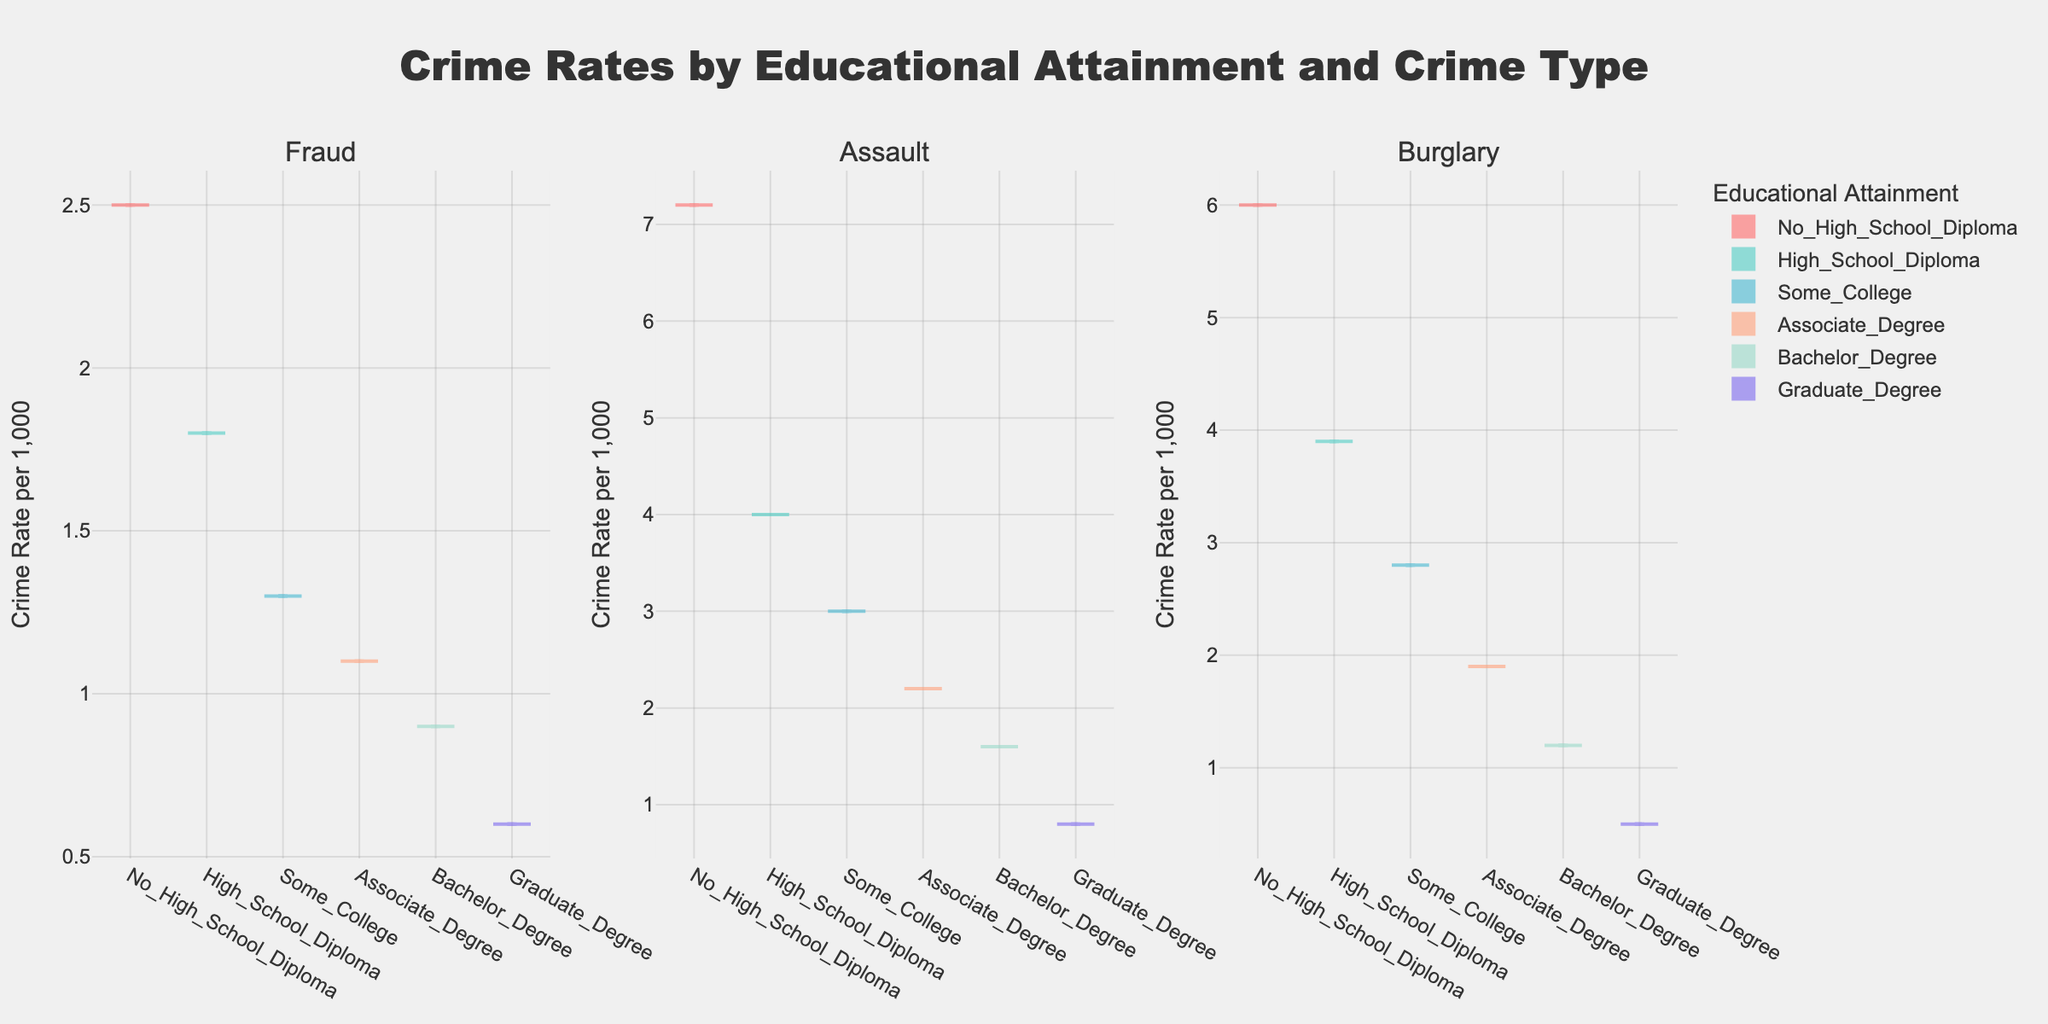What is the title of the plot? The title of the plot is displayed prominently at the top. It reads 'Crime Rates by Educational Attainment and Crime Type'.
Answer: Crime Rates by Educational Attainment and Crime Type How many different levels of educational attainment are compared in the plot? The plot uses different colors for each level of educational attainment. There are six distinct colors, indicating six levels.
Answer: Six Which crime type shows the highest crime rate among those with no high school diploma? For each subplot, find the violin plot corresponding to 'No_High_School_Diploma' and visually compare their lengths. The Assault subplot has the longest violin for 'No_High_School_Diploma'.
Answer: Assault Which crime type shows the lowest crime rate for individuals with a graduate degree? For each subplot, locate the violin for 'Graduate_Degree'. The Burglary subplot has the shortest violin for 'Graduate_Degree'.
Answer: Burglary Rank the crime rates of 'Fraud' for each level of educational attainment from highest to lowest. Identify the violins in the 'Fraud' subplot and visually compare their lengths. The order from longest to shortest is: No_High_School_Diploma, High_School_Diploma, Some_College, Associate_Degree, Bachelor_Degree, Graduate_Degree.
Answer: No_High_School_Diploma, High_School_Diploma, Some_College, Associate_Degree, Bachelor_Degree, Graduate_Degree Which plot shows the most significant decrease in crime rate as the level of educational attainment increases? Compare the trends across the subplots. The Assault subplot shows a consistent and significant drop in crime rates as the educational level increases.
Answer: Assault What is the general trend of crime rates with increasing educational attainment across all crime types? Observe the pattern of the violins in all subplots. Generally, crime rates decrease as the level of educational attainment increases.
Answer: Decreasing Among individuals with an associate degree, which crime type has the highest crime rate? Look at the violins associated with 'Associate_Degree' in each subplot and compare their lengths. The Assault subplot has the longest violin for 'Associate_Degree'.
Answer: Assault What is the mean crime rate for burglary in the 'Some_College' education level? In the Burglary subplot, locate the violin for 'Some_College'. The mean line is visible in the center of the violin, indicating the average crime rate.
Answer: 2.8 